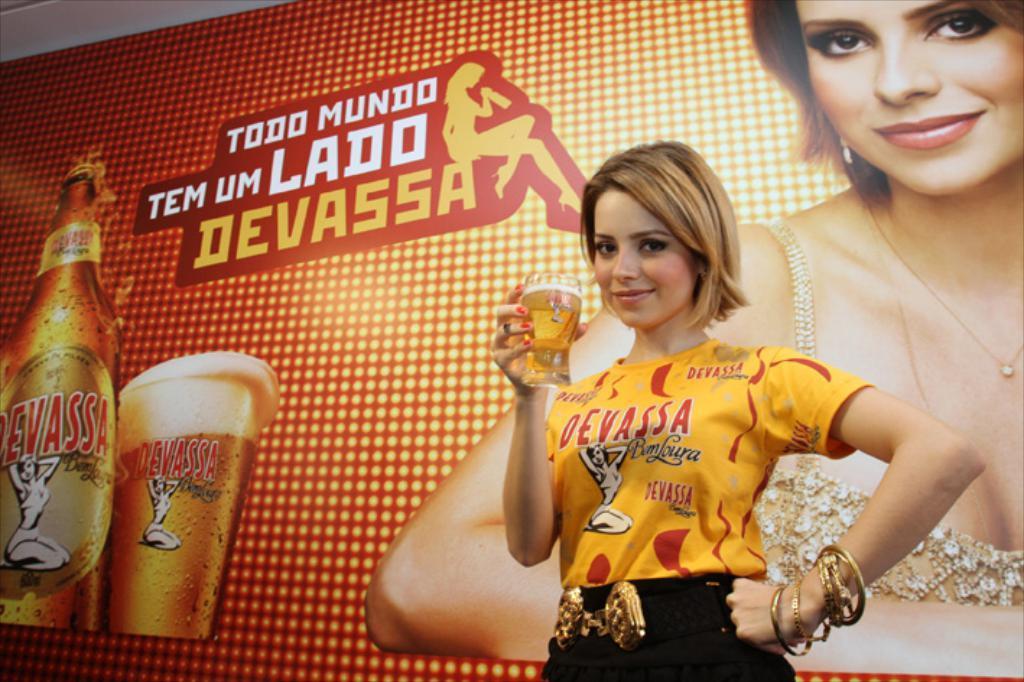Please provide a concise description of this image. I can see in this image of women is holding a glass in a hand use wearing yellow color t-shirt I am smiling with background I can see advertisement board. 